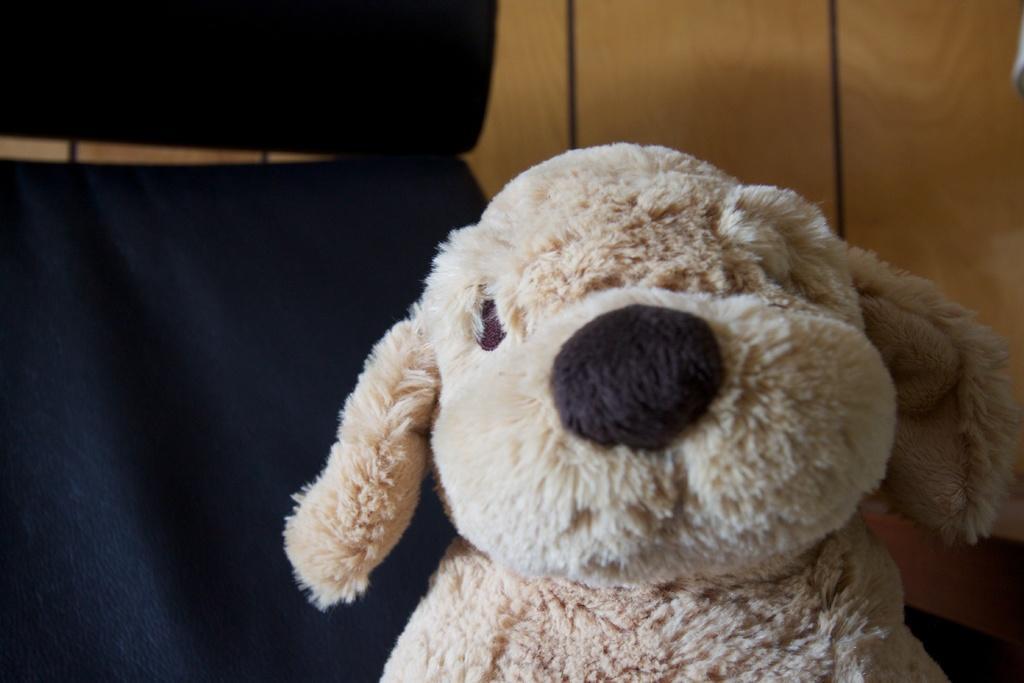Please provide a concise description of this image. In the foreground we can see a toy. On the left there is a black color object. In the background it is looking like a wooden object. 